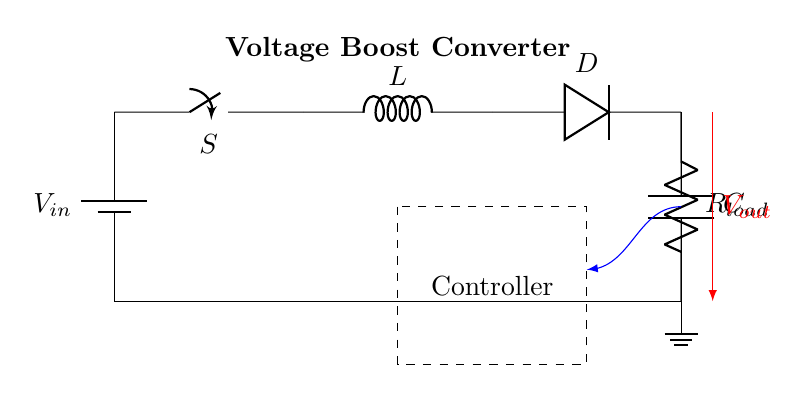What is the input voltage of the circuit? The input voltage is denoted as V_in, shown on the battery symbol at the left side of the circuit diagram.
Answer: V_in What is the role of the inductor in the circuit? The inductor, labeled L, is used to store energy and is crucial for the voltage boosting process in this converter.
Answer: Energy storage What type of switch is used in this circuit? The switch, labeled S, is depicted as a standard on-off switch, allowing control over the flow of current in the circuit.
Answer: On-off switch What component is responsible for allowing current to flow in one direction? The diode, labeled D in the circuit, permits current to pass only in one direction, protecting the circuit from reverse current.
Answer: Diode What is the purpose of the capacitor in this voltage boost converter? The capacitor, labeled C, smoothens the output voltage and stores the electrical energy, providing a stable voltage output for the load.
Answer: Smoothing output How does the circuit boost the voltage? The controller manages the operations of the switch and inductor, which alternates to store and release energy, thereby increasing the output voltage as indicated by V_out.
Answer: Through energy management What is the load resistance represented in this circuit? The load resistance is indicated by R_load, which represents the device or component that consumes power from the output of the voltage boost converter.
Answer: R_load 